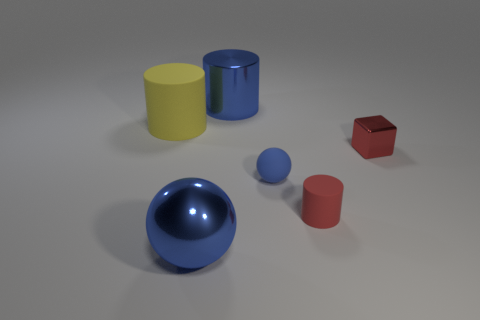Add 2 yellow matte cylinders. How many objects exist? 8 Subtract all balls. How many objects are left? 4 Add 4 small yellow metal things. How many small yellow metal things exist? 4 Subtract 0 gray balls. How many objects are left? 6 Subtract all tiny brown matte balls. Subtract all tiny metallic things. How many objects are left? 5 Add 5 big balls. How many big balls are left? 6 